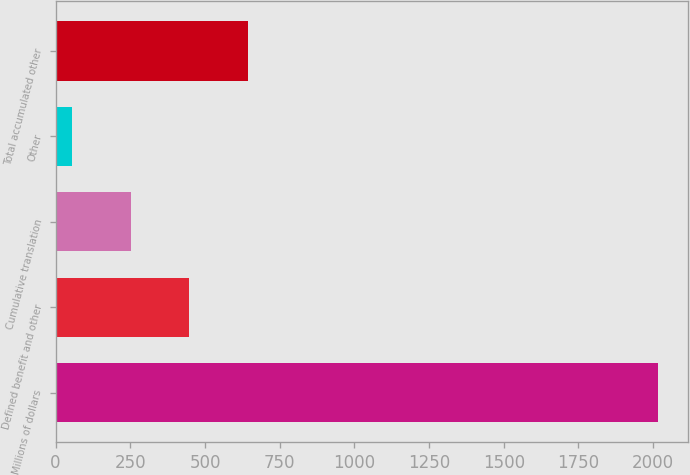<chart> <loc_0><loc_0><loc_500><loc_500><bar_chart><fcel>Millions of dollars<fcel>Defined benefit and other<fcel>Cumulative translation<fcel>Other<fcel>Total accumulated other<nl><fcel>2017<fcel>447.4<fcel>251.2<fcel>55<fcel>643.6<nl></chart> 